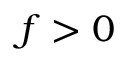Convert formula to latex. <formula><loc_0><loc_0><loc_500><loc_500>f > 0</formula> 